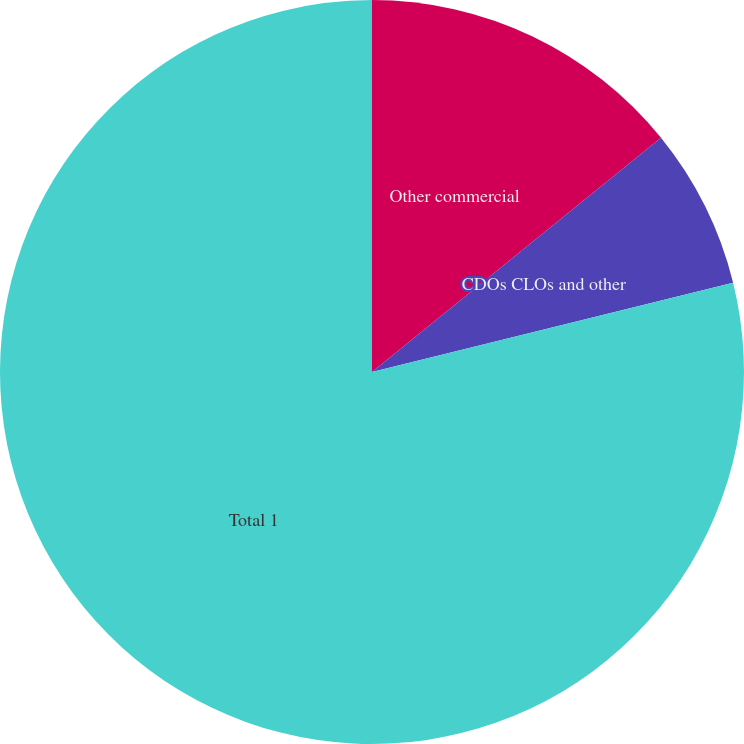Convert chart to OTSL. <chart><loc_0><loc_0><loc_500><loc_500><pie_chart><fcel>Other commercial<fcel>CDOs CLOs and other<fcel>Total 1<nl><fcel>14.16%<fcel>6.98%<fcel>78.86%<nl></chart> 